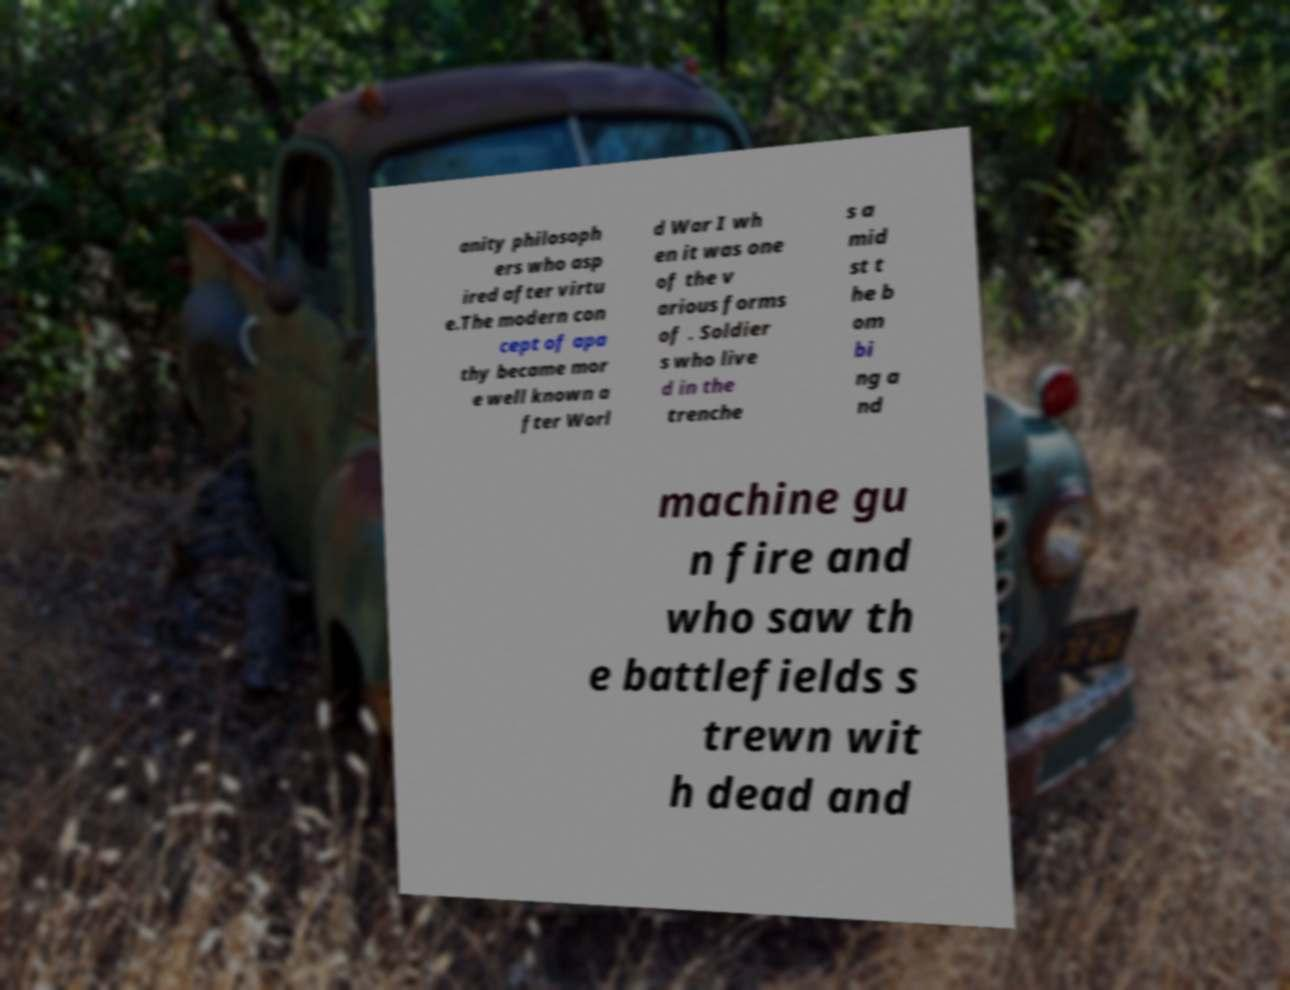I need the written content from this picture converted into text. Can you do that? anity philosoph ers who asp ired after virtu e.The modern con cept of apa thy became mor e well known a fter Worl d War I wh en it was one of the v arious forms of . Soldier s who live d in the trenche s a mid st t he b om bi ng a nd machine gu n fire and who saw th e battlefields s trewn wit h dead and 